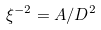Convert formula to latex. <formula><loc_0><loc_0><loc_500><loc_500>\xi ^ { - 2 } = A / D ^ { 2 }</formula> 